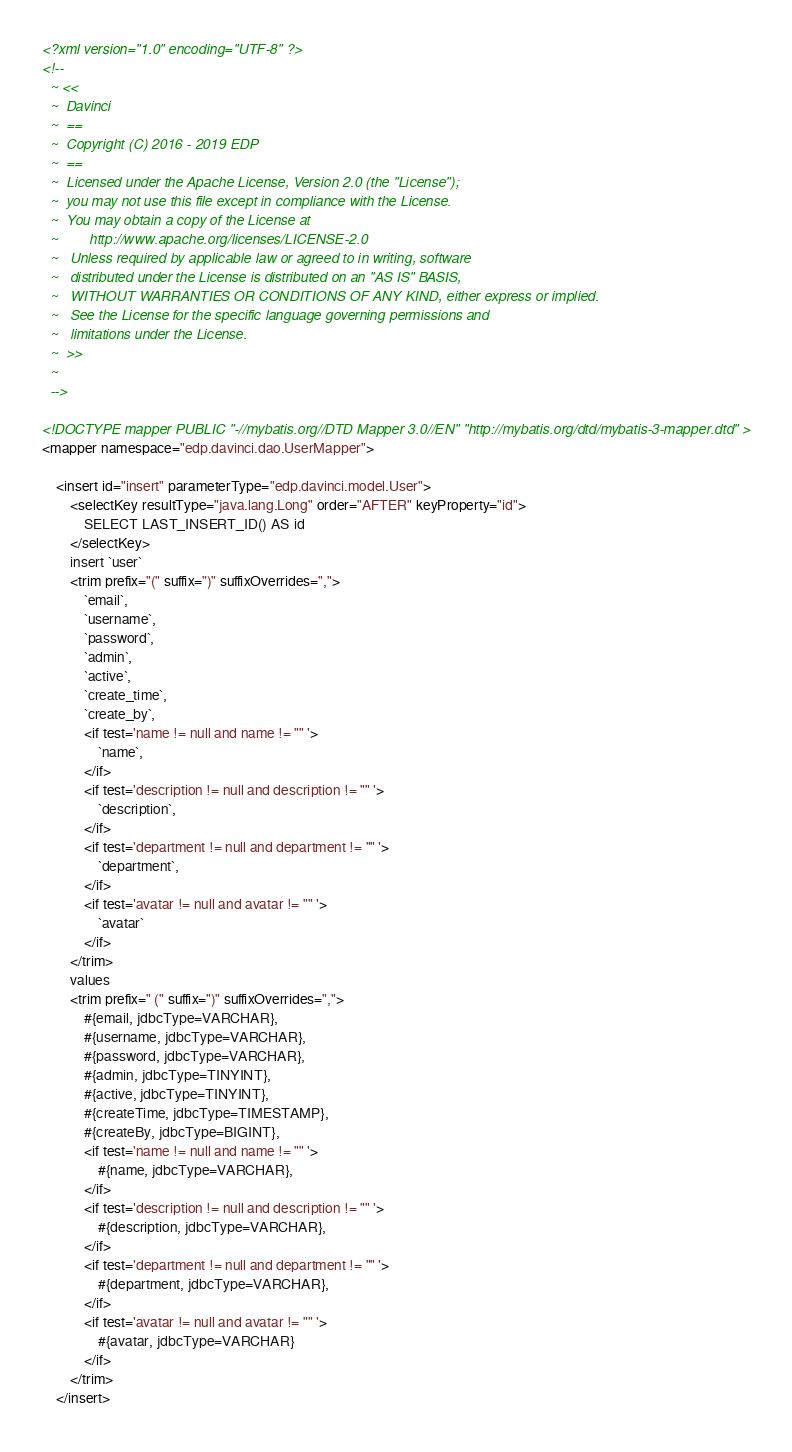<code> <loc_0><loc_0><loc_500><loc_500><_XML_><?xml version="1.0" encoding="UTF-8" ?>
<!--
  ~ <<
  ~  Davinci
  ~  ==
  ~  Copyright (C) 2016 - 2019 EDP
  ~  ==
  ~  Licensed under the Apache License, Version 2.0 (the "License");
  ~  you may not use this file except in compliance with the License.
  ~  You may obtain a copy of the License at
  ~        http://www.apache.org/licenses/LICENSE-2.0
  ~   Unless required by applicable law or agreed to in writing, software
  ~   distributed under the License is distributed on an "AS IS" BASIS,
  ~   WITHOUT WARRANTIES OR CONDITIONS OF ANY KIND, either express or implied.
  ~   See the License for the specific language governing permissions and
  ~   limitations under the License.
  ~  >>
  ~
  -->

<!DOCTYPE mapper PUBLIC "-//mybatis.org//DTD Mapper 3.0//EN" "http://mybatis.org/dtd/mybatis-3-mapper.dtd" >
<mapper namespace="edp.davinci.dao.UserMapper">

    <insert id="insert" parameterType="edp.davinci.model.User">
        <selectKey resultType="java.lang.Long" order="AFTER" keyProperty="id">
            SELECT LAST_INSERT_ID() AS id
        </selectKey>
        insert `user`
        <trim prefix="(" suffix=")" suffixOverrides=",">
            `email`,
            `username`,
            `password`,
            `admin`,
            `active`,
            `create_time`,
            `create_by`,
            <if test='name != null and name != "" '>
                `name`,
            </if>
            <if test='description != null and description != "" '>
                `description`,
            </if>
            <if test='department != null and department != "" '>
                `department`,
            </if>
            <if test='avatar != null and avatar != "" '>
                `avatar`
            </if>
        </trim>
        values
        <trim prefix=" (" suffix=")" suffixOverrides=",">
            #{email, jdbcType=VARCHAR},
            #{username, jdbcType=VARCHAR},
            #{password, jdbcType=VARCHAR},
            #{admin, jdbcType=TINYINT},
            #{active, jdbcType=TINYINT},
            #{createTime, jdbcType=TIMESTAMP},
            #{createBy, jdbcType=BIGINT},
            <if test='name != null and name != "" '>
                #{name, jdbcType=VARCHAR},
            </if>
            <if test='description != null and description != "" '>
                #{description, jdbcType=VARCHAR},
            </if>
            <if test='department != null and department != "" '>
                #{department, jdbcType=VARCHAR},
            </if>
            <if test='avatar != null and avatar != "" '>
                #{avatar, jdbcType=VARCHAR}
            </if>
        </trim>
    </insert>

</code> 